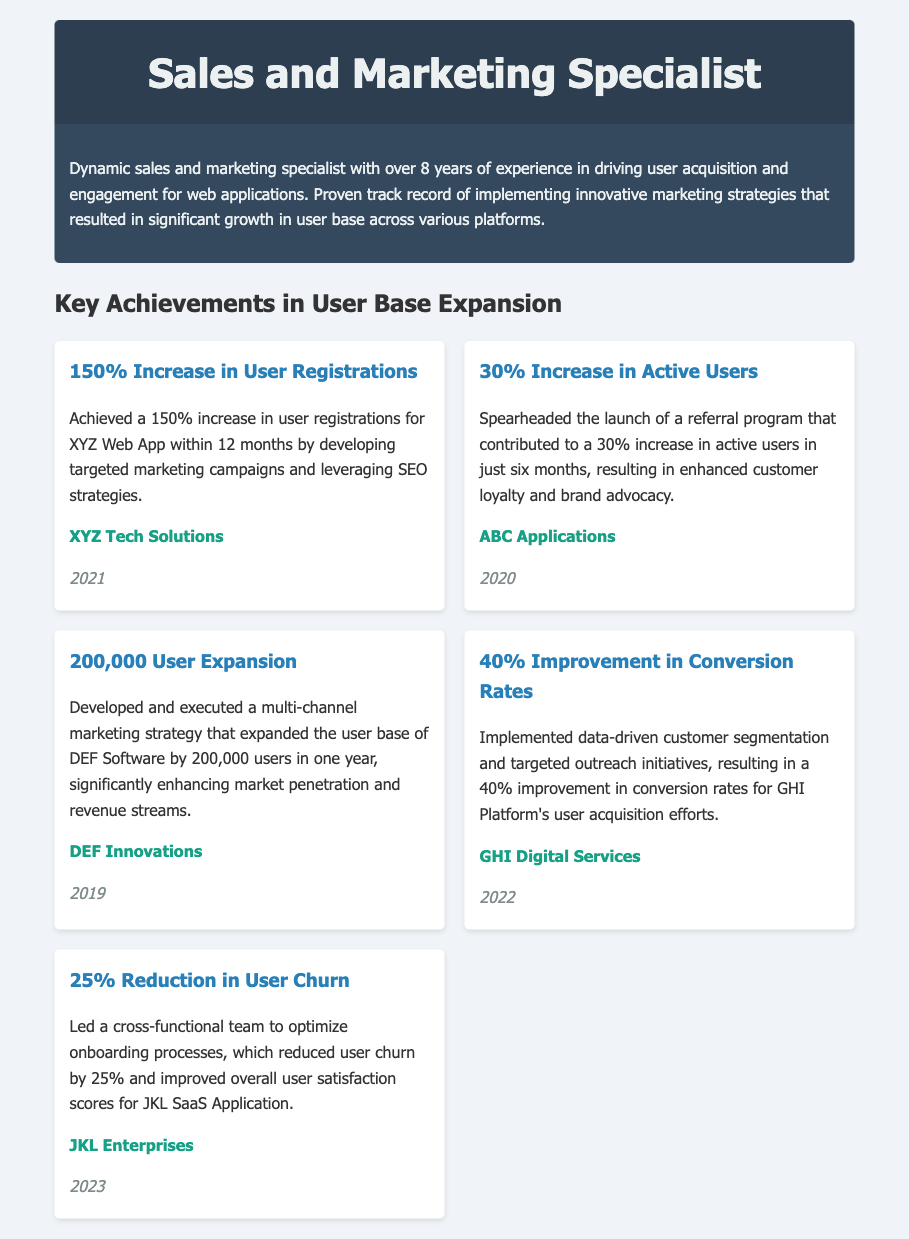What is the total increase in user registrations achieved for XYZ Web App? The total increase is a percentage value mentioned in the document.
Answer: 150% Which company implemented a referral program? The company that launched the referral program is mentioned in connection with the achievement of increasing active users.
Answer: ABC Applications In what year did the user expansion of 200,000 users occur? The year is specified in the context of the achievement related to the user expansion.
Answer: 2019 What was the percentage improvement in conversion rates for GHI Platform? This percentage is stated in the achievement section for the GHI Platform.
Answer: 40% What was the reduction in user churn for JKL SaaS Application? The specific percentage of churn reduction is provided in connection with the onboarding process optimization mentioned in the document.
Answer: 25% Which company achieved a 30% increase in active users? This company is highlighted in the achievement related to the referral program.
Answer: ABC Applications What year did DEF Innovations expand its user base by 200,000 users? The document states the year in the achievement section related to DEF Innovations.
Answer: 2019 What type of marketing strategies did the specialist implement? The type of strategies is mentioned in the context of driving user acquisition and engagement.
Answer: Innovative marketing strategies 